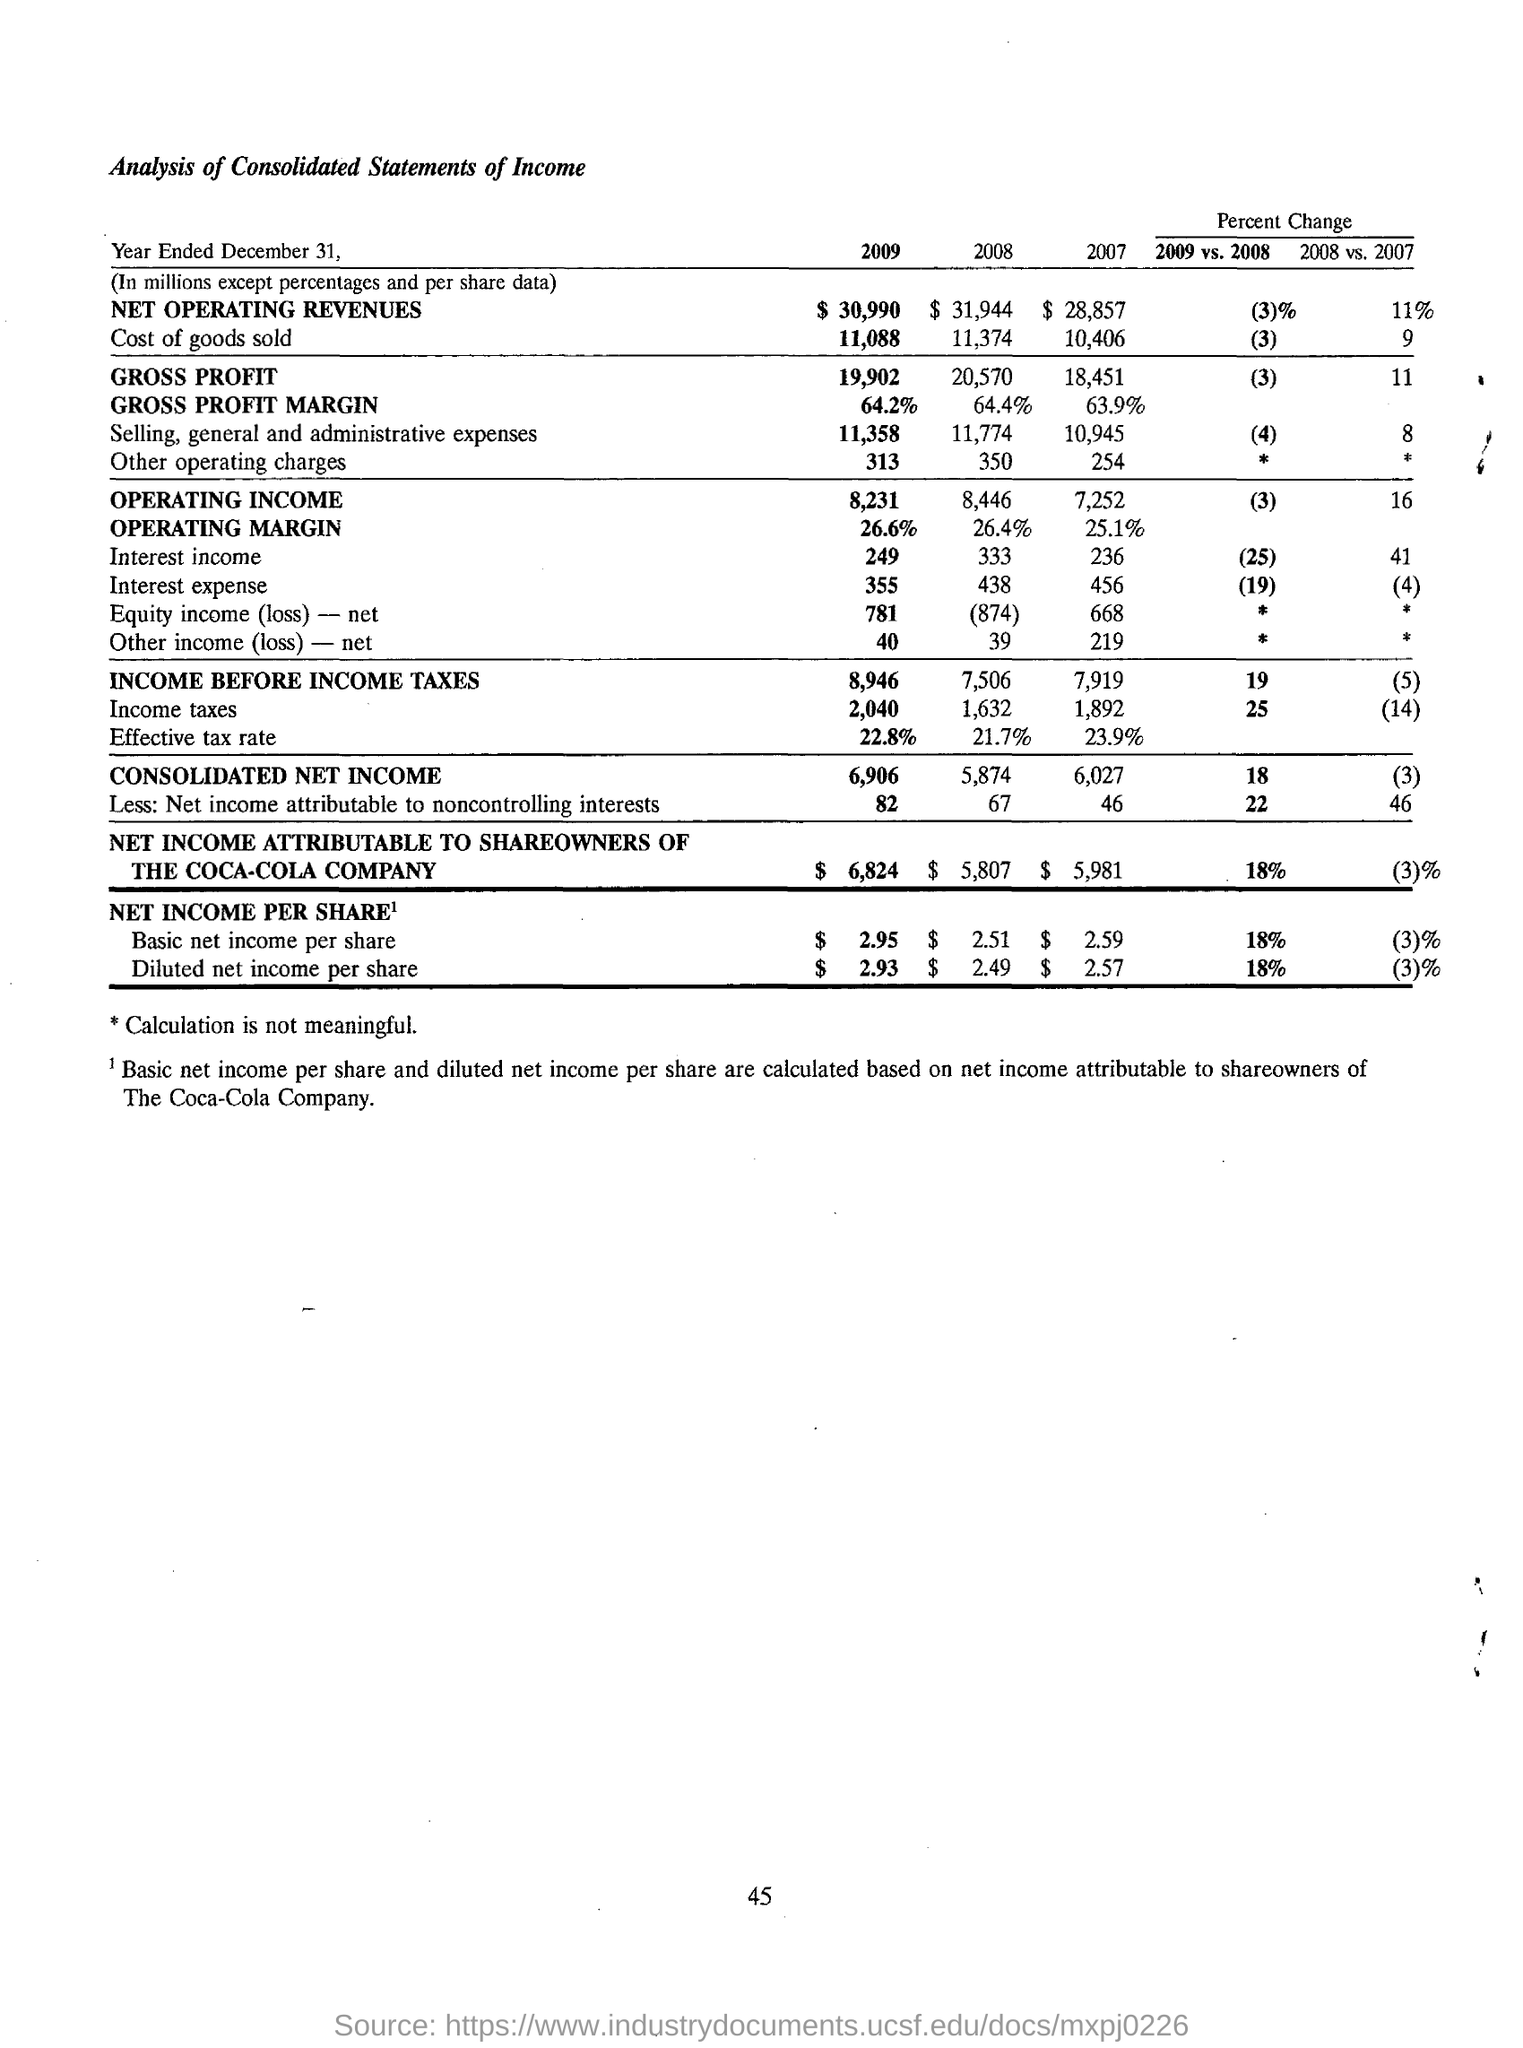Specify some key components in this picture. In the year 2007, the income before income tax was 7,919 millions. The gross profit in the year 2009 was 19,902 million. The consolidated net income in the year 2008 was 5,874. In the year 2009, the operating margin was 26.6%. In 2009, the basic net income per share was 18% higher than in 2008. 